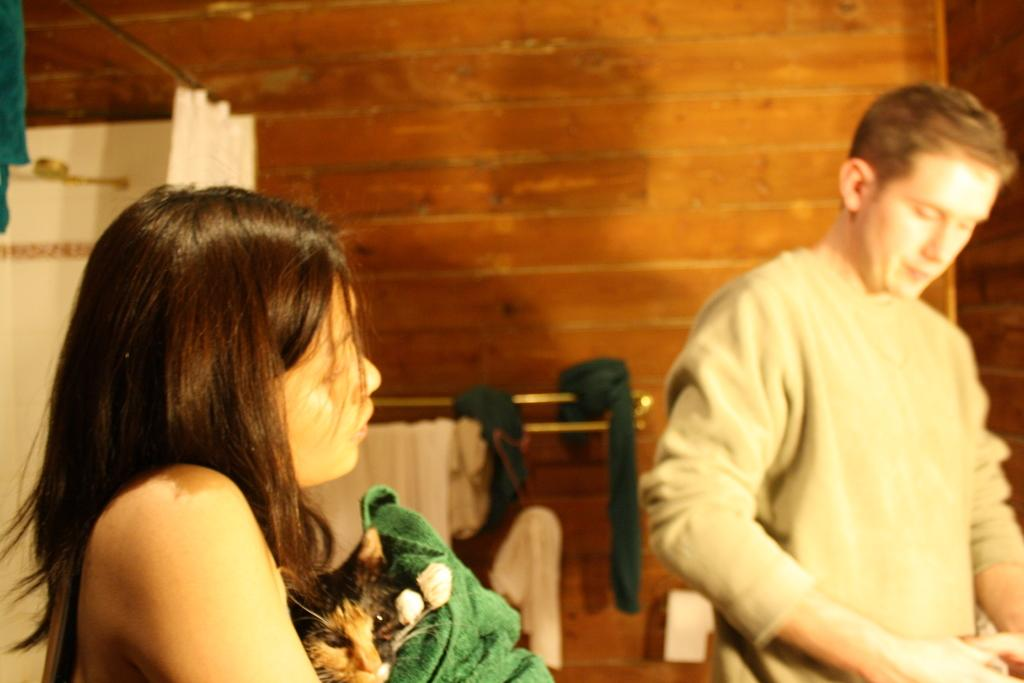What is the main subject of the image? The main subject of the image is a woman. What is the woman doing in the image? The woman is holding a cat in her hands. Are there any other people in the image? Yes, there is a man in the image. How is the man positioned in relation to the woman? The man is a little bit away from the woman. What is the woman's belief about the governor's voice in the image? There is no mention of a governor or any beliefs in the image; it simply shows a woman holding a cat and a man nearby. 